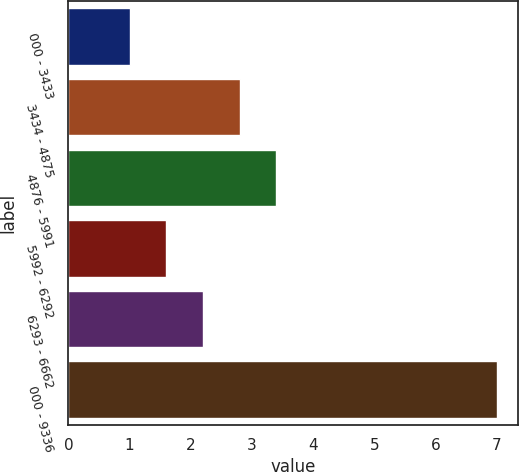Convert chart. <chart><loc_0><loc_0><loc_500><loc_500><bar_chart><fcel>000 - 3433<fcel>3434 - 4875<fcel>4876 - 5991<fcel>5992 - 6292<fcel>6293 - 6662<fcel>000 - 9336<nl><fcel>1<fcel>2.8<fcel>3.4<fcel>1.6<fcel>2.2<fcel>7<nl></chart> 